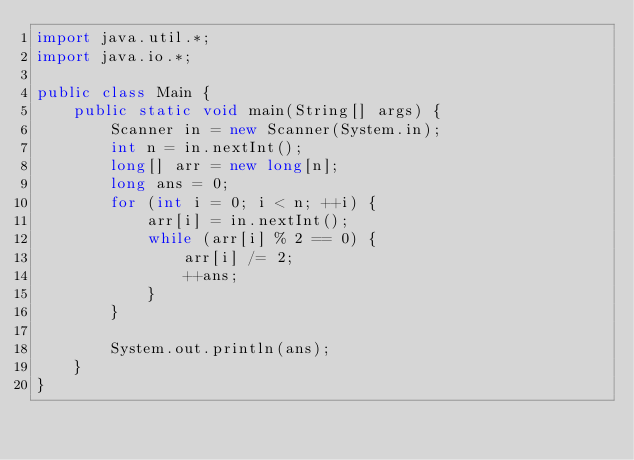Convert code to text. <code><loc_0><loc_0><loc_500><loc_500><_Java_>import java.util.*;
import java.io.*;

public class Main {
    public static void main(String[] args) {
        Scanner in = new Scanner(System.in);
        int n = in.nextInt();
        long[] arr = new long[n];
        long ans = 0;
        for (int i = 0; i < n; ++i) {
            arr[i] = in.nextInt();
            while (arr[i] % 2 == 0) {
                arr[i] /= 2;
                ++ans;
            }
        }

        System.out.println(ans);
    }
}</code> 